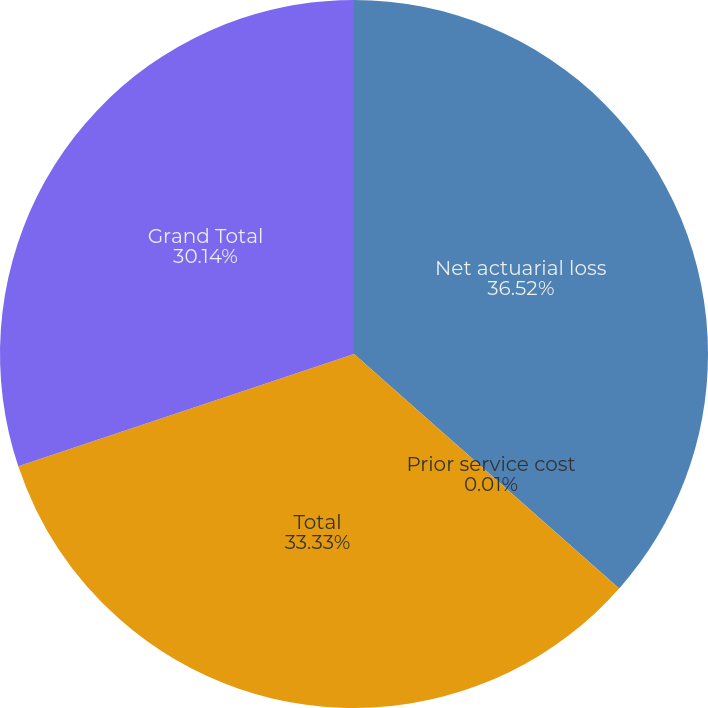Convert chart. <chart><loc_0><loc_0><loc_500><loc_500><pie_chart><fcel>Net actuarial loss<fcel>Prior service cost<fcel>Total<fcel>Grand Total<nl><fcel>36.52%<fcel>0.01%<fcel>33.33%<fcel>30.14%<nl></chart> 